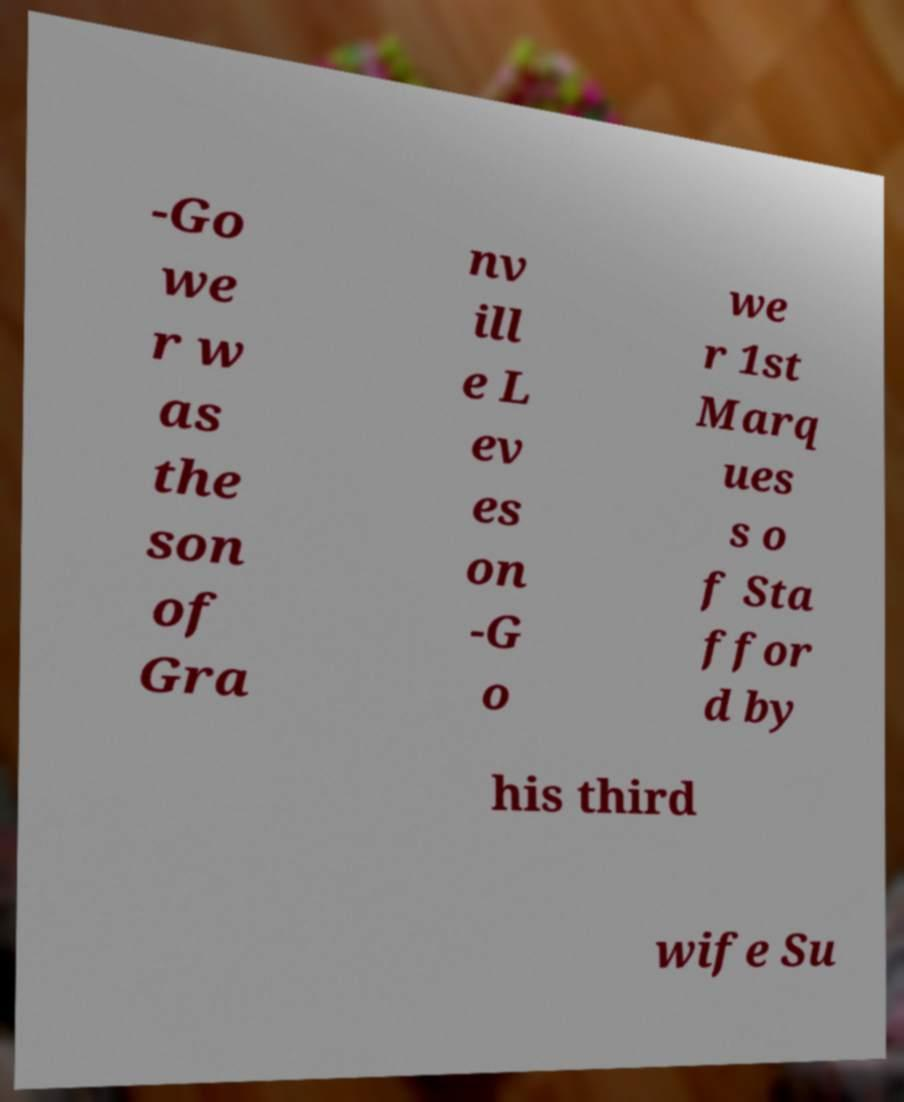There's text embedded in this image that I need extracted. Can you transcribe it verbatim? -Go we r w as the son of Gra nv ill e L ev es on -G o we r 1st Marq ues s o f Sta ffor d by his third wife Su 